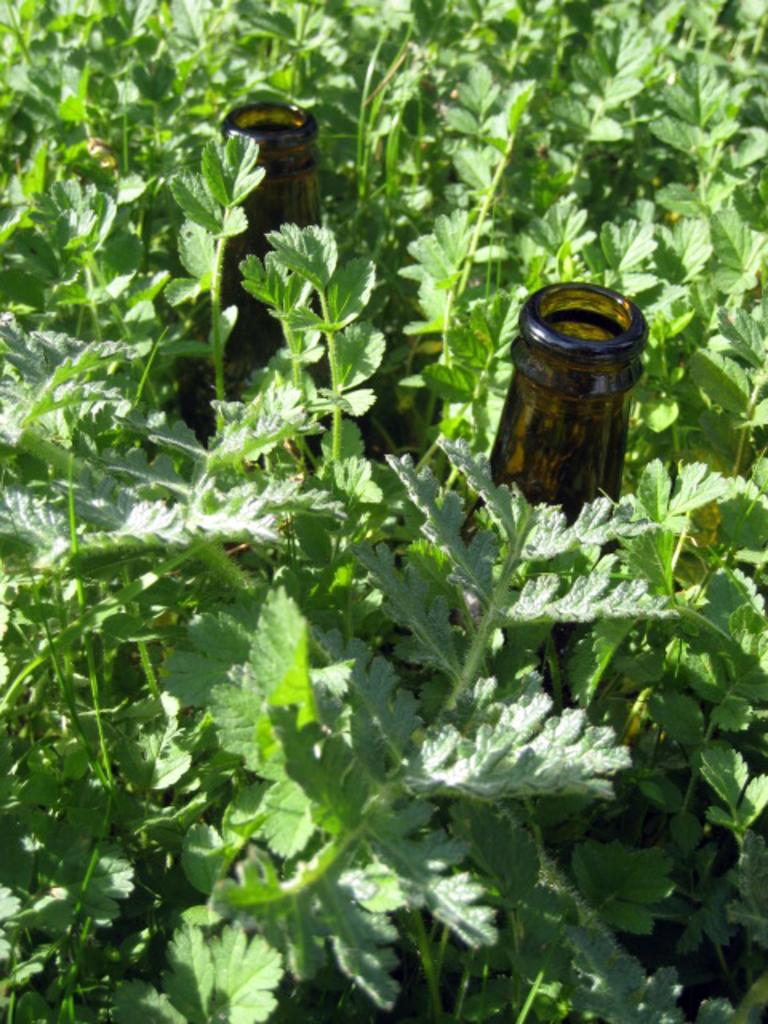What type of plants are in the image? There are green plants in the image. How many glass bottles are in the image? There are two glass bottles in the image. Where are the glass bottles located in relation to the plants? The glass bottles are in the middle of the plants. What type of cord is connecting the plants in the image? There is no cord connecting the plants in the image; they are not physically connected. 